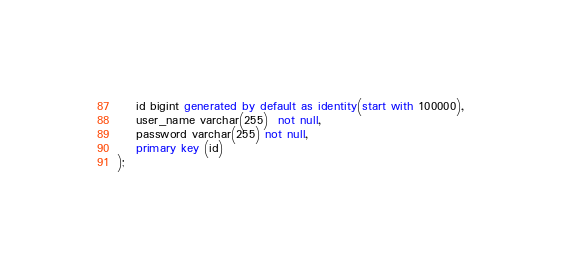<code> <loc_0><loc_0><loc_500><loc_500><_SQL_>	id bigint generated by default as identity(start with 100000),
	user_name varchar(255)  not null,
	password varchar(255) not null,
	primary key (id)
);
</code> 